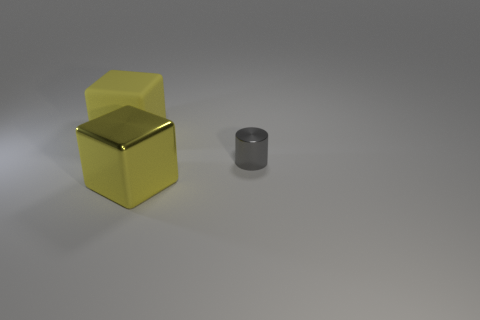Add 2 matte balls. How many objects exist? 5 Subtract all blocks. How many objects are left? 1 Add 1 small things. How many small things exist? 2 Subtract 0 cyan cylinders. How many objects are left? 3 Subtract all small objects. Subtract all large matte objects. How many objects are left? 1 Add 3 metallic things. How many metallic things are left? 5 